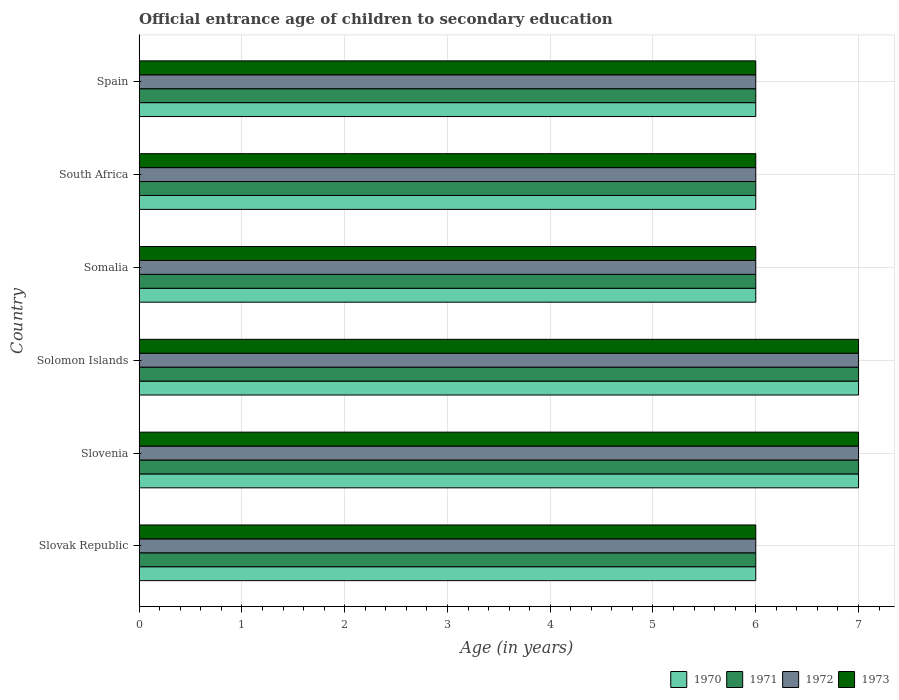What is the label of the 3rd group of bars from the top?
Your response must be concise. Somalia. In how many cases, is the number of bars for a given country not equal to the number of legend labels?
Give a very brief answer. 0. In which country was the secondary school starting age of children in 1973 maximum?
Your response must be concise. Slovenia. In which country was the secondary school starting age of children in 1973 minimum?
Offer a very short reply. Slovak Republic. What is the total secondary school starting age of children in 1973 in the graph?
Give a very brief answer. 38. What is the difference between the secondary school starting age of children in 1970 in Slovak Republic and that in Somalia?
Offer a terse response. 0. What is the difference between the secondary school starting age of children in 1972 in Somalia and the secondary school starting age of children in 1971 in Slovak Republic?
Offer a terse response. 0. What is the average secondary school starting age of children in 1970 per country?
Ensure brevity in your answer.  6.33. What is the ratio of the secondary school starting age of children in 1971 in Slovenia to that in Spain?
Make the answer very short. 1.17. Is the secondary school starting age of children in 1973 in Slovenia less than that in South Africa?
Make the answer very short. No. Is it the case that in every country, the sum of the secondary school starting age of children in 1972 and secondary school starting age of children in 1973 is greater than the sum of secondary school starting age of children in 1970 and secondary school starting age of children in 1971?
Provide a succinct answer. No. How many bars are there?
Offer a terse response. 24. Are the values on the major ticks of X-axis written in scientific E-notation?
Ensure brevity in your answer.  No. Does the graph contain any zero values?
Ensure brevity in your answer.  No. How are the legend labels stacked?
Provide a succinct answer. Horizontal. What is the title of the graph?
Make the answer very short. Official entrance age of children to secondary education. What is the label or title of the X-axis?
Your answer should be compact. Age (in years). What is the Age (in years) of 1970 in Slovak Republic?
Provide a short and direct response. 6. What is the Age (in years) in 1972 in Slovak Republic?
Your answer should be very brief. 6. What is the Age (in years) in 1971 in Slovenia?
Offer a very short reply. 7. What is the Age (in years) in 1972 in Slovenia?
Make the answer very short. 7. What is the Age (in years) in 1971 in Solomon Islands?
Your response must be concise. 7. What is the Age (in years) in 1970 in Somalia?
Provide a succinct answer. 6. What is the Age (in years) in 1971 in Somalia?
Provide a short and direct response. 6. What is the Age (in years) in 1972 in Somalia?
Your answer should be very brief. 6. What is the Age (in years) of 1971 in South Africa?
Make the answer very short. 6. What is the Age (in years) of 1972 in South Africa?
Your answer should be compact. 6. What is the Age (in years) of 1973 in Spain?
Provide a short and direct response. 6. Across all countries, what is the maximum Age (in years) in 1970?
Your answer should be compact. 7. Across all countries, what is the maximum Age (in years) of 1971?
Your answer should be very brief. 7. Across all countries, what is the maximum Age (in years) of 1972?
Give a very brief answer. 7. Across all countries, what is the maximum Age (in years) in 1973?
Give a very brief answer. 7. Across all countries, what is the minimum Age (in years) of 1970?
Offer a very short reply. 6. Across all countries, what is the minimum Age (in years) in 1971?
Your response must be concise. 6. Across all countries, what is the minimum Age (in years) in 1973?
Your answer should be very brief. 6. What is the total Age (in years) in 1973 in the graph?
Keep it short and to the point. 38. What is the difference between the Age (in years) of 1972 in Slovak Republic and that in Slovenia?
Your answer should be very brief. -1. What is the difference between the Age (in years) of 1973 in Slovak Republic and that in Slovenia?
Offer a very short reply. -1. What is the difference between the Age (in years) in 1971 in Slovak Republic and that in Solomon Islands?
Offer a terse response. -1. What is the difference between the Age (in years) in 1973 in Slovak Republic and that in Solomon Islands?
Keep it short and to the point. -1. What is the difference between the Age (in years) in 1970 in Slovak Republic and that in Somalia?
Your answer should be compact. 0. What is the difference between the Age (in years) in 1972 in Slovak Republic and that in Somalia?
Your answer should be very brief. 0. What is the difference between the Age (in years) of 1970 in Slovak Republic and that in South Africa?
Your answer should be very brief. 0. What is the difference between the Age (in years) in 1973 in Slovak Republic and that in South Africa?
Your answer should be very brief. 0. What is the difference between the Age (in years) of 1970 in Slovak Republic and that in Spain?
Provide a succinct answer. 0. What is the difference between the Age (in years) in 1972 in Slovak Republic and that in Spain?
Your answer should be very brief. 0. What is the difference between the Age (in years) of 1973 in Slovak Republic and that in Spain?
Offer a very short reply. 0. What is the difference between the Age (in years) in 1972 in Slovenia and that in Solomon Islands?
Keep it short and to the point. 0. What is the difference between the Age (in years) of 1972 in Slovenia and that in Somalia?
Provide a short and direct response. 1. What is the difference between the Age (in years) in 1973 in Slovenia and that in Somalia?
Your answer should be compact. 1. What is the difference between the Age (in years) of 1971 in Slovenia and that in South Africa?
Your response must be concise. 1. What is the difference between the Age (in years) in 1970 in Slovenia and that in Spain?
Offer a terse response. 1. What is the difference between the Age (in years) of 1971 in Slovenia and that in Spain?
Keep it short and to the point. 1. What is the difference between the Age (in years) in 1971 in Solomon Islands and that in Somalia?
Offer a very short reply. 1. What is the difference between the Age (in years) of 1973 in Solomon Islands and that in Somalia?
Your answer should be compact. 1. What is the difference between the Age (in years) in 1972 in Solomon Islands and that in Spain?
Your answer should be very brief. 1. What is the difference between the Age (in years) of 1973 in Solomon Islands and that in Spain?
Ensure brevity in your answer.  1. What is the difference between the Age (in years) in 1972 in Somalia and that in South Africa?
Provide a succinct answer. 0. What is the difference between the Age (in years) in 1973 in Somalia and that in South Africa?
Ensure brevity in your answer.  0. What is the difference between the Age (in years) of 1970 in Somalia and that in Spain?
Your response must be concise. 0. What is the difference between the Age (in years) of 1971 in Somalia and that in Spain?
Provide a succinct answer. 0. What is the difference between the Age (in years) of 1970 in South Africa and that in Spain?
Keep it short and to the point. 0. What is the difference between the Age (in years) in 1971 in South Africa and that in Spain?
Offer a very short reply. 0. What is the difference between the Age (in years) in 1972 in South Africa and that in Spain?
Your response must be concise. 0. What is the difference between the Age (in years) of 1973 in South Africa and that in Spain?
Your answer should be compact. 0. What is the difference between the Age (in years) of 1970 in Slovak Republic and the Age (in years) of 1971 in Slovenia?
Provide a succinct answer. -1. What is the difference between the Age (in years) in 1970 in Slovak Republic and the Age (in years) in 1972 in Slovenia?
Provide a short and direct response. -1. What is the difference between the Age (in years) in 1970 in Slovak Republic and the Age (in years) in 1973 in Slovenia?
Make the answer very short. -1. What is the difference between the Age (in years) in 1971 in Slovak Republic and the Age (in years) in 1972 in Slovenia?
Your answer should be very brief. -1. What is the difference between the Age (in years) in 1970 in Slovak Republic and the Age (in years) in 1972 in Solomon Islands?
Give a very brief answer. -1. What is the difference between the Age (in years) of 1970 in Slovak Republic and the Age (in years) of 1973 in Solomon Islands?
Keep it short and to the point. -1. What is the difference between the Age (in years) in 1971 in Slovak Republic and the Age (in years) in 1972 in Solomon Islands?
Keep it short and to the point. -1. What is the difference between the Age (in years) in 1972 in Slovak Republic and the Age (in years) in 1973 in Solomon Islands?
Offer a very short reply. -1. What is the difference between the Age (in years) in 1970 in Slovak Republic and the Age (in years) in 1971 in South Africa?
Provide a short and direct response. 0. What is the difference between the Age (in years) in 1970 in Slovak Republic and the Age (in years) in 1972 in South Africa?
Make the answer very short. 0. What is the difference between the Age (in years) of 1971 in Slovak Republic and the Age (in years) of 1972 in South Africa?
Provide a short and direct response. 0. What is the difference between the Age (in years) of 1971 in Slovak Republic and the Age (in years) of 1973 in South Africa?
Keep it short and to the point. 0. What is the difference between the Age (in years) of 1970 in Slovak Republic and the Age (in years) of 1971 in Spain?
Offer a very short reply. 0. What is the difference between the Age (in years) in 1970 in Slovak Republic and the Age (in years) in 1972 in Spain?
Your answer should be very brief. 0. What is the difference between the Age (in years) in 1971 in Slovak Republic and the Age (in years) in 1973 in Spain?
Provide a short and direct response. 0. What is the difference between the Age (in years) of 1970 in Slovenia and the Age (in years) of 1972 in Solomon Islands?
Provide a short and direct response. 0. What is the difference between the Age (in years) of 1970 in Slovenia and the Age (in years) of 1972 in Somalia?
Your answer should be very brief. 1. What is the difference between the Age (in years) in 1970 in Slovenia and the Age (in years) in 1973 in Somalia?
Provide a short and direct response. 1. What is the difference between the Age (in years) of 1971 in Slovenia and the Age (in years) of 1972 in Somalia?
Your answer should be very brief. 1. What is the difference between the Age (in years) of 1971 in Slovenia and the Age (in years) of 1973 in Somalia?
Give a very brief answer. 1. What is the difference between the Age (in years) in 1972 in Slovenia and the Age (in years) in 1973 in Somalia?
Provide a short and direct response. 1. What is the difference between the Age (in years) in 1971 in Slovenia and the Age (in years) in 1972 in South Africa?
Your answer should be compact. 1. What is the difference between the Age (in years) in 1972 in Slovenia and the Age (in years) in 1973 in South Africa?
Offer a terse response. 1. What is the difference between the Age (in years) of 1970 in Slovenia and the Age (in years) of 1971 in Spain?
Make the answer very short. 1. What is the difference between the Age (in years) of 1971 in Slovenia and the Age (in years) of 1972 in Spain?
Give a very brief answer. 1. What is the difference between the Age (in years) of 1971 in Slovenia and the Age (in years) of 1973 in Spain?
Keep it short and to the point. 1. What is the difference between the Age (in years) in 1970 in Solomon Islands and the Age (in years) in 1971 in Somalia?
Your response must be concise. 1. What is the difference between the Age (in years) of 1970 in Solomon Islands and the Age (in years) of 1972 in Somalia?
Ensure brevity in your answer.  1. What is the difference between the Age (in years) in 1970 in Solomon Islands and the Age (in years) in 1973 in Somalia?
Make the answer very short. 1. What is the difference between the Age (in years) of 1971 in Solomon Islands and the Age (in years) of 1972 in Somalia?
Offer a terse response. 1. What is the difference between the Age (in years) in 1972 in Solomon Islands and the Age (in years) in 1973 in Somalia?
Provide a short and direct response. 1. What is the difference between the Age (in years) in 1970 in Solomon Islands and the Age (in years) in 1971 in South Africa?
Give a very brief answer. 1. What is the difference between the Age (in years) of 1972 in Solomon Islands and the Age (in years) of 1973 in South Africa?
Provide a succinct answer. 1. What is the difference between the Age (in years) in 1971 in Solomon Islands and the Age (in years) in 1972 in Spain?
Your response must be concise. 1. What is the difference between the Age (in years) of 1972 in Solomon Islands and the Age (in years) of 1973 in Spain?
Ensure brevity in your answer.  1. What is the difference between the Age (in years) of 1970 in Somalia and the Age (in years) of 1971 in South Africa?
Your answer should be compact. 0. What is the difference between the Age (in years) of 1970 in Somalia and the Age (in years) of 1973 in South Africa?
Keep it short and to the point. 0. What is the difference between the Age (in years) of 1971 in Somalia and the Age (in years) of 1972 in South Africa?
Provide a short and direct response. 0. What is the difference between the Age (in years) of 1970 in Somalia and the Age (in years) of 1971 in Spain?
Ensure brevity in your answer.  0. What is the difference between the Age (in years) of 1972 in Somalia and the Age (in years) of 1973 in Spain?
Give a very brief answer. 0. What is the difference between the Age (in years) of 1972 in South Africa and the Age (in years) of 1973 in Spain?
Keep it short and to the point. 0. What is the average Age (in years) in 1970 per country?
Make the answer very short. 6.33. What is the average Age (in years) in 1971 per country?
Your answer should be very brief. 6.33. What is the average Age (in years) of 1972 per country?
Your answer should be very brief. 6.33. What is the average Age (in years) in 1973 per country?
Make the answer very short. 6.33. What is the difference between the Age (in years) of 1970 and Age (in years) of 1971 in Slovak Republic?
Make the answer very short. 0. What is the difference between the Age (in years) in 1970 and Age (in years) in 1972 in Slovak Republic?
Keep it short and to the point. 0. What is the difference between the Age (in years) in 1971 and Age (in years) in 1972 in Slovak Republic?
Offer a terse response. 0. What is the difference between the Age (in years) of 1971 and Age (in years) of 1973 in Slovak Republic?
Offer a very short reply. 0. What is the difference between the Age (in years) in 1972 and Age (in years) in 1973 in Slovak Republic?
Ensure brevity in your answer.  0. What is the difference between the Age (in years) of 1970 and Age (in years) of 1971 in Slovenia?
Keep it short and to the point. 0. What is the difference between the Age (in years) of 1970 and Age (in years) of 1973 in Slovenia?
Keep it short and to the point. 0. What is the difference between the Age (in years) of 1972 and Age (in years) of 1973 in Slovenia?
Keep it short and to the point. 0. What is the difference between the Age (in years) in 1970 and Age (in years) in 1971 in Solomon Islands?
Provide a succinct answer. 0. What is the difference between the Age (in years) of 1972 and Age (in years) of 1973 in Solomon Islands?
Ensure brevity in your answer.  0. What is the difference between the Age (in years) in 1970 and Age (in years) in 1972 in Somalia?
Provide a succinct answer. 0. What is the difference between the Age (in years) in 1970 and Age (in years) in 1973 in Somalia?
Give a very brief answer. 0. What is the difference between the Age (in years) of 1971 and Age (in years) of 1973 in Somalia?
Provide a succinct answer. 0. What is the difference between the Age (in years) in 1970 and Age (in years) in 1971 in South Africa?
Your answer should be very brief. 0. What is the difference between the Age (in years) in 1970 and Age (in years) in 1972 in South Africa?
Ensure brevity in your answer.  0. What is the difference between the Age (in years) of 1970 and Age (in years) of 1973 in South Africa?
Offer a terse response. 0. What is the difference between the Age (in years) in 1972 and Age (in years) in 1973 in South Africa?
Your answer should be compact. 0. What is the difference between the Age (in years) of 1970 and Age (in years) of 1972 in Spain?
Provide a succinct answer. 0. What is the difference between the Age (in years) of 1970 and Age (in years) of 1973 in Spain?
Ensure brevity in your answer.  0. What is the difference between the Age (in years) of 1971 and Age (in years) of 1973 in Spain?
Keep it short and to the point. 0. What is the difference between the Age (in years) of 1972 and Age (in years) of 1973 in Spain?
Give a very brief answer. 0. What is the ratio of the Age (in years) of 1970 in Slovak Republic to that in Slovenia?
Ensure brevity in your answer.  0.86. What is the ratio of the Age (in years) of 1972 in Slovak Republic to that in Solomon Islands?
Your answer should be compact. 0.86. What is the ratio of the Age (in years) of 1973 in Slovak Republic to that in Solomon Islands?
Your answer should be very brief. 0.86. What is the ratio of the Age (in years) in 1970 in Slovak Republic to that in Somalia?
Make the answer very short. 1. What is the ratio of the Age (in years) in 1971 in Slovak Republic to that in Somalia?
Offer a very short reply. 1. What is the ratio of the Age (in years) of 1973 in Slovak Republic to that in Somalia?
Your response must be concise. 1. What is the ratio of the Age (in years) of 1970 in Slovak Republic to that in South Africa?
Provide a short and direct response. 1. What is the ratio of the Age (in years) in 1971 in Slovak Republic to that in South Africa?
Make the answer very short. 1. What is the ratio of the Age (in years) in 1971 in Slovak Republic to that in Spain?
Your answer should be compact. 1. What is the ratio of the Age (in years) in 1973 in Slovak Republic to that in Spain?
Your answer should be very brief. 1. What is the ratio of the Age (in years) in 1971 in Slovenia to that in Solomon Islands?
Make the answer very short. 1. What is the ratio of the Age (in years) in 1972 in Slovenia to that in Solomon Islands?
Give a very brief answer. 1. What is the ratio of the Age (in years) in 1973 in Slovenia to that in Solomon Islands?
Give a very brief answer. 1. What is the ratio of the Age (in years) of 1973 in Slovenia to that in Somalia?
Offer a very short reply. 1.17. What is the ratio of the Age (in years) in 1970 in Slovenia to that in South Africa?
Your answer should be very brief. 1.17. What is the ratio of the Age (in years) of 1973 in Slovenia to that in South Africa?
Keep it short and to the point. 1.17. What is the ratio of the Age (in years) in 1972 in Slovenia to that in Spain?
Provide a succinct answer. 1.17. What is the ratio of the Age (in years) of 1971 in Solomon Islands to that in Somalia?
Your response must be concise. 1.17. What is the ratio of the Age (in years) of 1970 in Solomon Islands to that in South Africa?
Give a very brief answer. 1.17. What is the ratio of the Age (in years) in 1971 in Solomon Islands to that in South Africa?
Give a very brief answer. 1.17. What is the ratio of the Age (in years) of 1972 in Solomon Islands to that in South Africa?
Ensure brevity in your answer.  1.17. What is the ratio of the Age (in years) of 1970 in Solomon Islands to that in Spain?
Your answer should be compact. 1.17. What is the ratio of the Age (in years) of 1972 in Solomon Islands to that in Spain?
Your answer should be compact. 1.17. What is the ratio of the Age (in years) in 1970 in Somalia to that in South Africa?
Keep it short and to the point. 1. What is the ratio of the Age (in years) in 1970 in Somalia to that in Spain?
Ensure brevity in your answer.  1. What is the ratio of the Age (in years) of 1971 in Somalia to that in Spain?
Your answer should be compact. 1. What is the ratio of the Age (in years) in 1973 in Somalia to that in Spain?
Provide a short and direct response. 1. What is the difference between the highest and the second highest Age (in years) of 1971?
Offer a very short reply. 0. What is the difference between the highest and the second highest Age (in years) of 1972?
Keep it short and to the point. 0. What is the difference between the highest and the second highest Age (in years) of 1973?
Ensure brevity in your answer.  0. What is the difference between the highest and the lowest Age (in years) in 1970?
Your response must be concise. 1. 